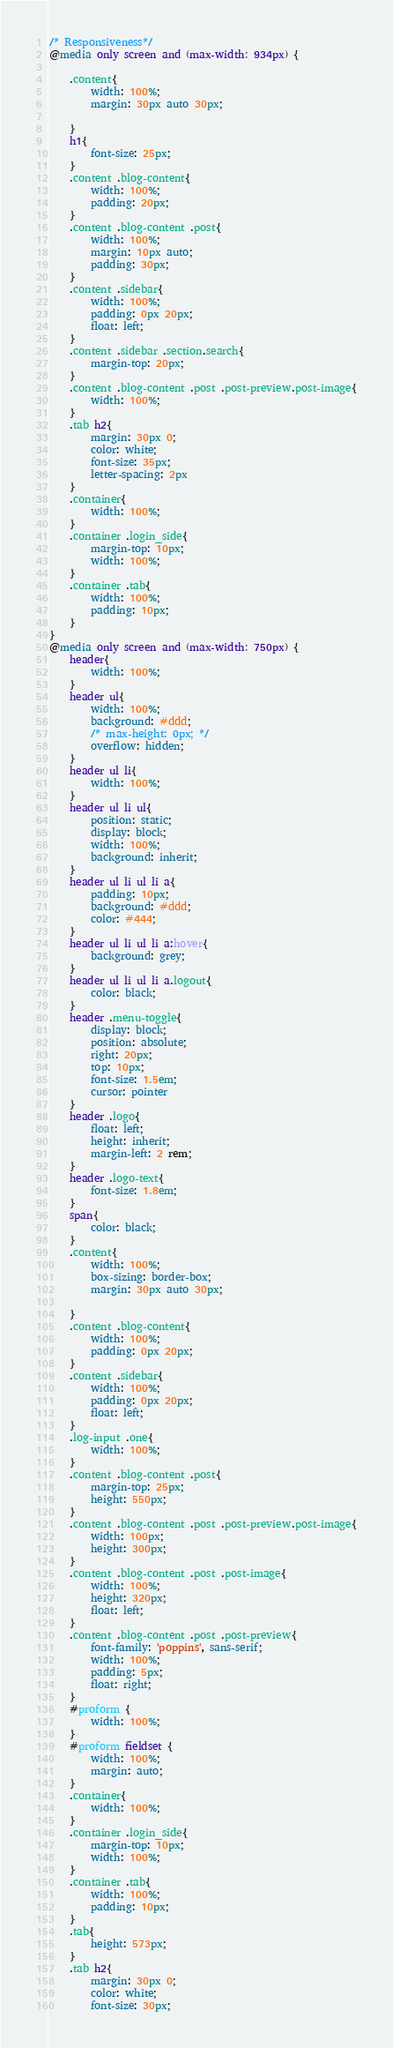<code> <loc_0><loc_0><loc_500><loc_500><_CSS_>/* Responsiveness*/
@media only screen and (max-width: 934px) {
    
    .content{
        width: 100%;
        margin: 30px auto 30px; 
        
    }
    h1{
        font-size: 25px;
    }
    .content .blog-content{
        width: 100%;
        padding: 20px;
    }
    .content .blog-content .post{
        width: 100%;
        margin: 10px auto;
        padding: 30px;
    }
    .content .sidebar{
        width: 100%;
        padding: 0px 20px;
        float: left;
    }
    .content .sidebar .section.search{
        margin-top: 20px;
    }
    .content .blog-content .post .post-preview.post-image{
        width: 100%;
    }
    .tab h2{
        margin: 30px 0;
        color: white;
        font-size: 35px;
        letter-spacing: 2px
    }
    .container{
        width: 100%;
    }
    .container .login_side{
        margin-top: 10px;
        width: 100%;
    }
    .container .tab{
        width: 100%;
        padding: 10px;
    }
}
@media only screen and (max-width: 750px) {
    header{
        width: 100%;
    }
    header ul{
        width: 100%;
        background: #ddd;
        /* max-height: 0px; */
        overflow: hidden;
    }
    header ul li{
        width: 100%;
    }
    header ul li ul{
        position: static;
        display: block;
        width: 100%;
        background: inherit;
    }
    header ul li ul li a{
        padding: 10px;
        background: #ddd;
        color: #444;
    }
    header ul li ul li a:hover{
        background: grey;
    }
    header ul li ul li a.logout{
        color: black;
    }
    header .menu-toggle{
        display: block;
        position: absolute;
        right: 20px;
        top: 10px;
        font-size: 1.5em;
        cursor: pointer
    }
    header .logo{
        float: left;
        height: inherit;
        margin-left: 2 rem;
    }
    header .logo-text{
        font-size: 1.8em;
    }
    span{
        color: black;
    }
    .content{
        width: 100%;
        box-sizing: border-box;
        margin: 30px auto 30px;
        
    }
    .content .blog-content{
        width: 100%;
        padding: 0px 20px;
    }
    .content .sidebar{
        width: 100%;
        padding: 0px 20px;
        float: left;
    }
    .log-input .one{
        width: 100%;
    }
    .content .blog-content .post{
        margin-top: 25px;
        height: 550px;
    }
    .content .blog-content .post .post-preview.post-image{
        width: 100px;
        height: 300px;
    }
    .content .blog-content .post .post-image{
        width: 100%;
        height: 320px;
        float: left;
    }
    .content .blog-content .post .post-preview{
        font-family: 'poppins', sans-serif;
        width: 100%;
        padding: 5px;
        float: right;
    } 
    #proform {
        width: 100%;
    }
    #proform fieldset {
        width: 100%;
        margin: auto;
    }
    .container{
        width: 100%;
    }
    .container .login_side{
        margin-top: 10px;
        width: 100%;
    }
    .container .tab{
        width: 100%;
        padding: 10px;
    }
    .tab{
        height: 573px;
    }
    .tab h2{
        margin: 30px 0;
        color: white;
        font-size: 30px;</code> 